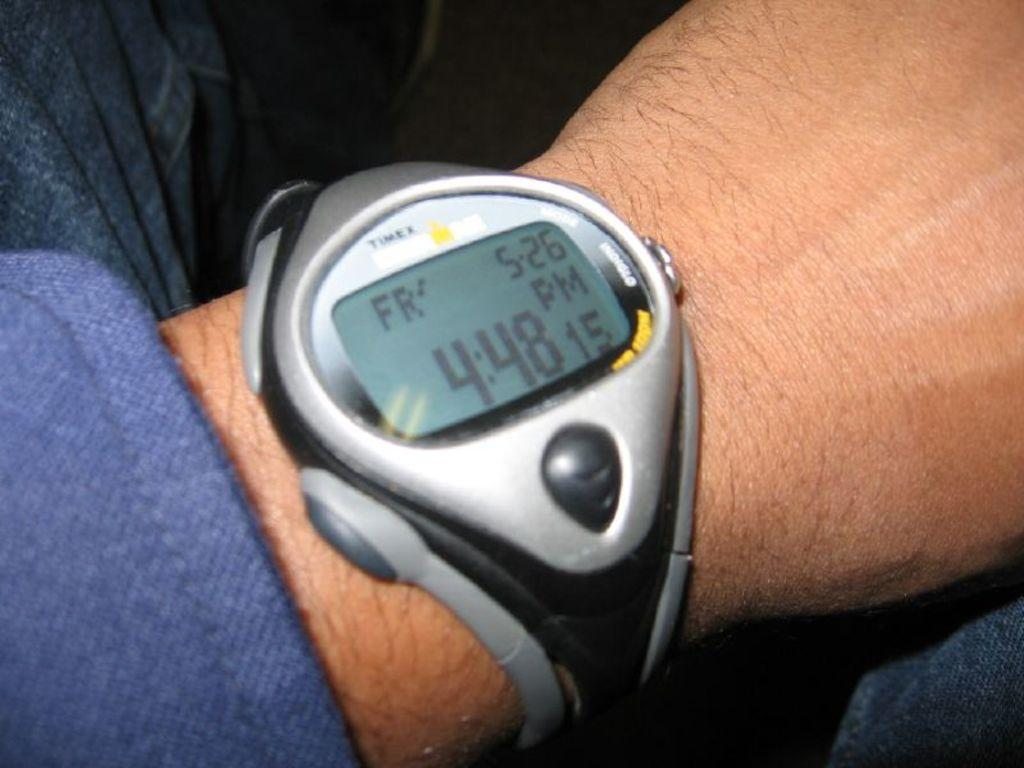<image>
Share a concise interpretation of the image provided. A man showing the time 4:48 on his watch. 